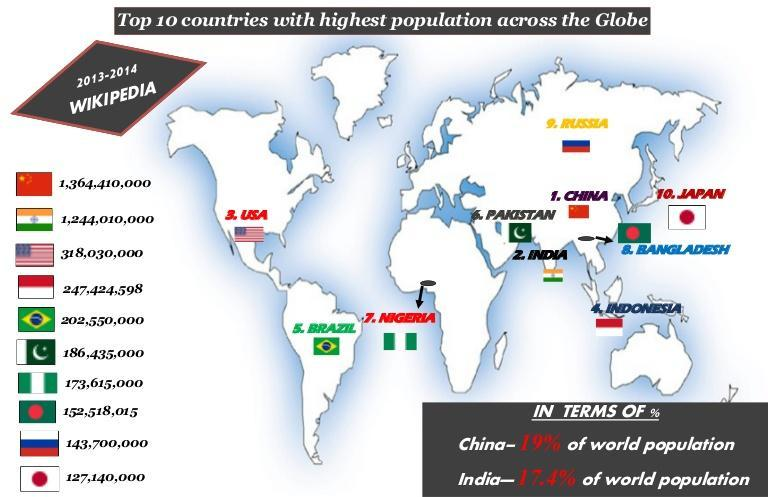what is the population of Nigeria according to this infographic?
Answer the question with a short phrase. 173615000 Which country has fourth largest population in the world according to this infographic? Indonesia Which country has third largest population in the world according to this infographic? USA which country is positioned just below Bangladesh in the list of top 10 countries with highest population? Russia what is the population of Russia according to this infographic? 143700000 Which country has fifth largest population in the world according to this infographic? Brazil what is the population of India according to this infographic? 1244010000 Which are the countries with population more than a billion? China, India which country is positioned just below Pakistan in the list of top 10 countries with highest population? Nigeria what is the total percentage of population of India and China combined? 36.4% Which country has second largest population in the world according to this infographic? India Which country has 10th largest population in the world according to this infographic? Japan which countries are positioned below Nigeria in the list of top 10 countries with highest population? Bangladesh, Russia, Japan 